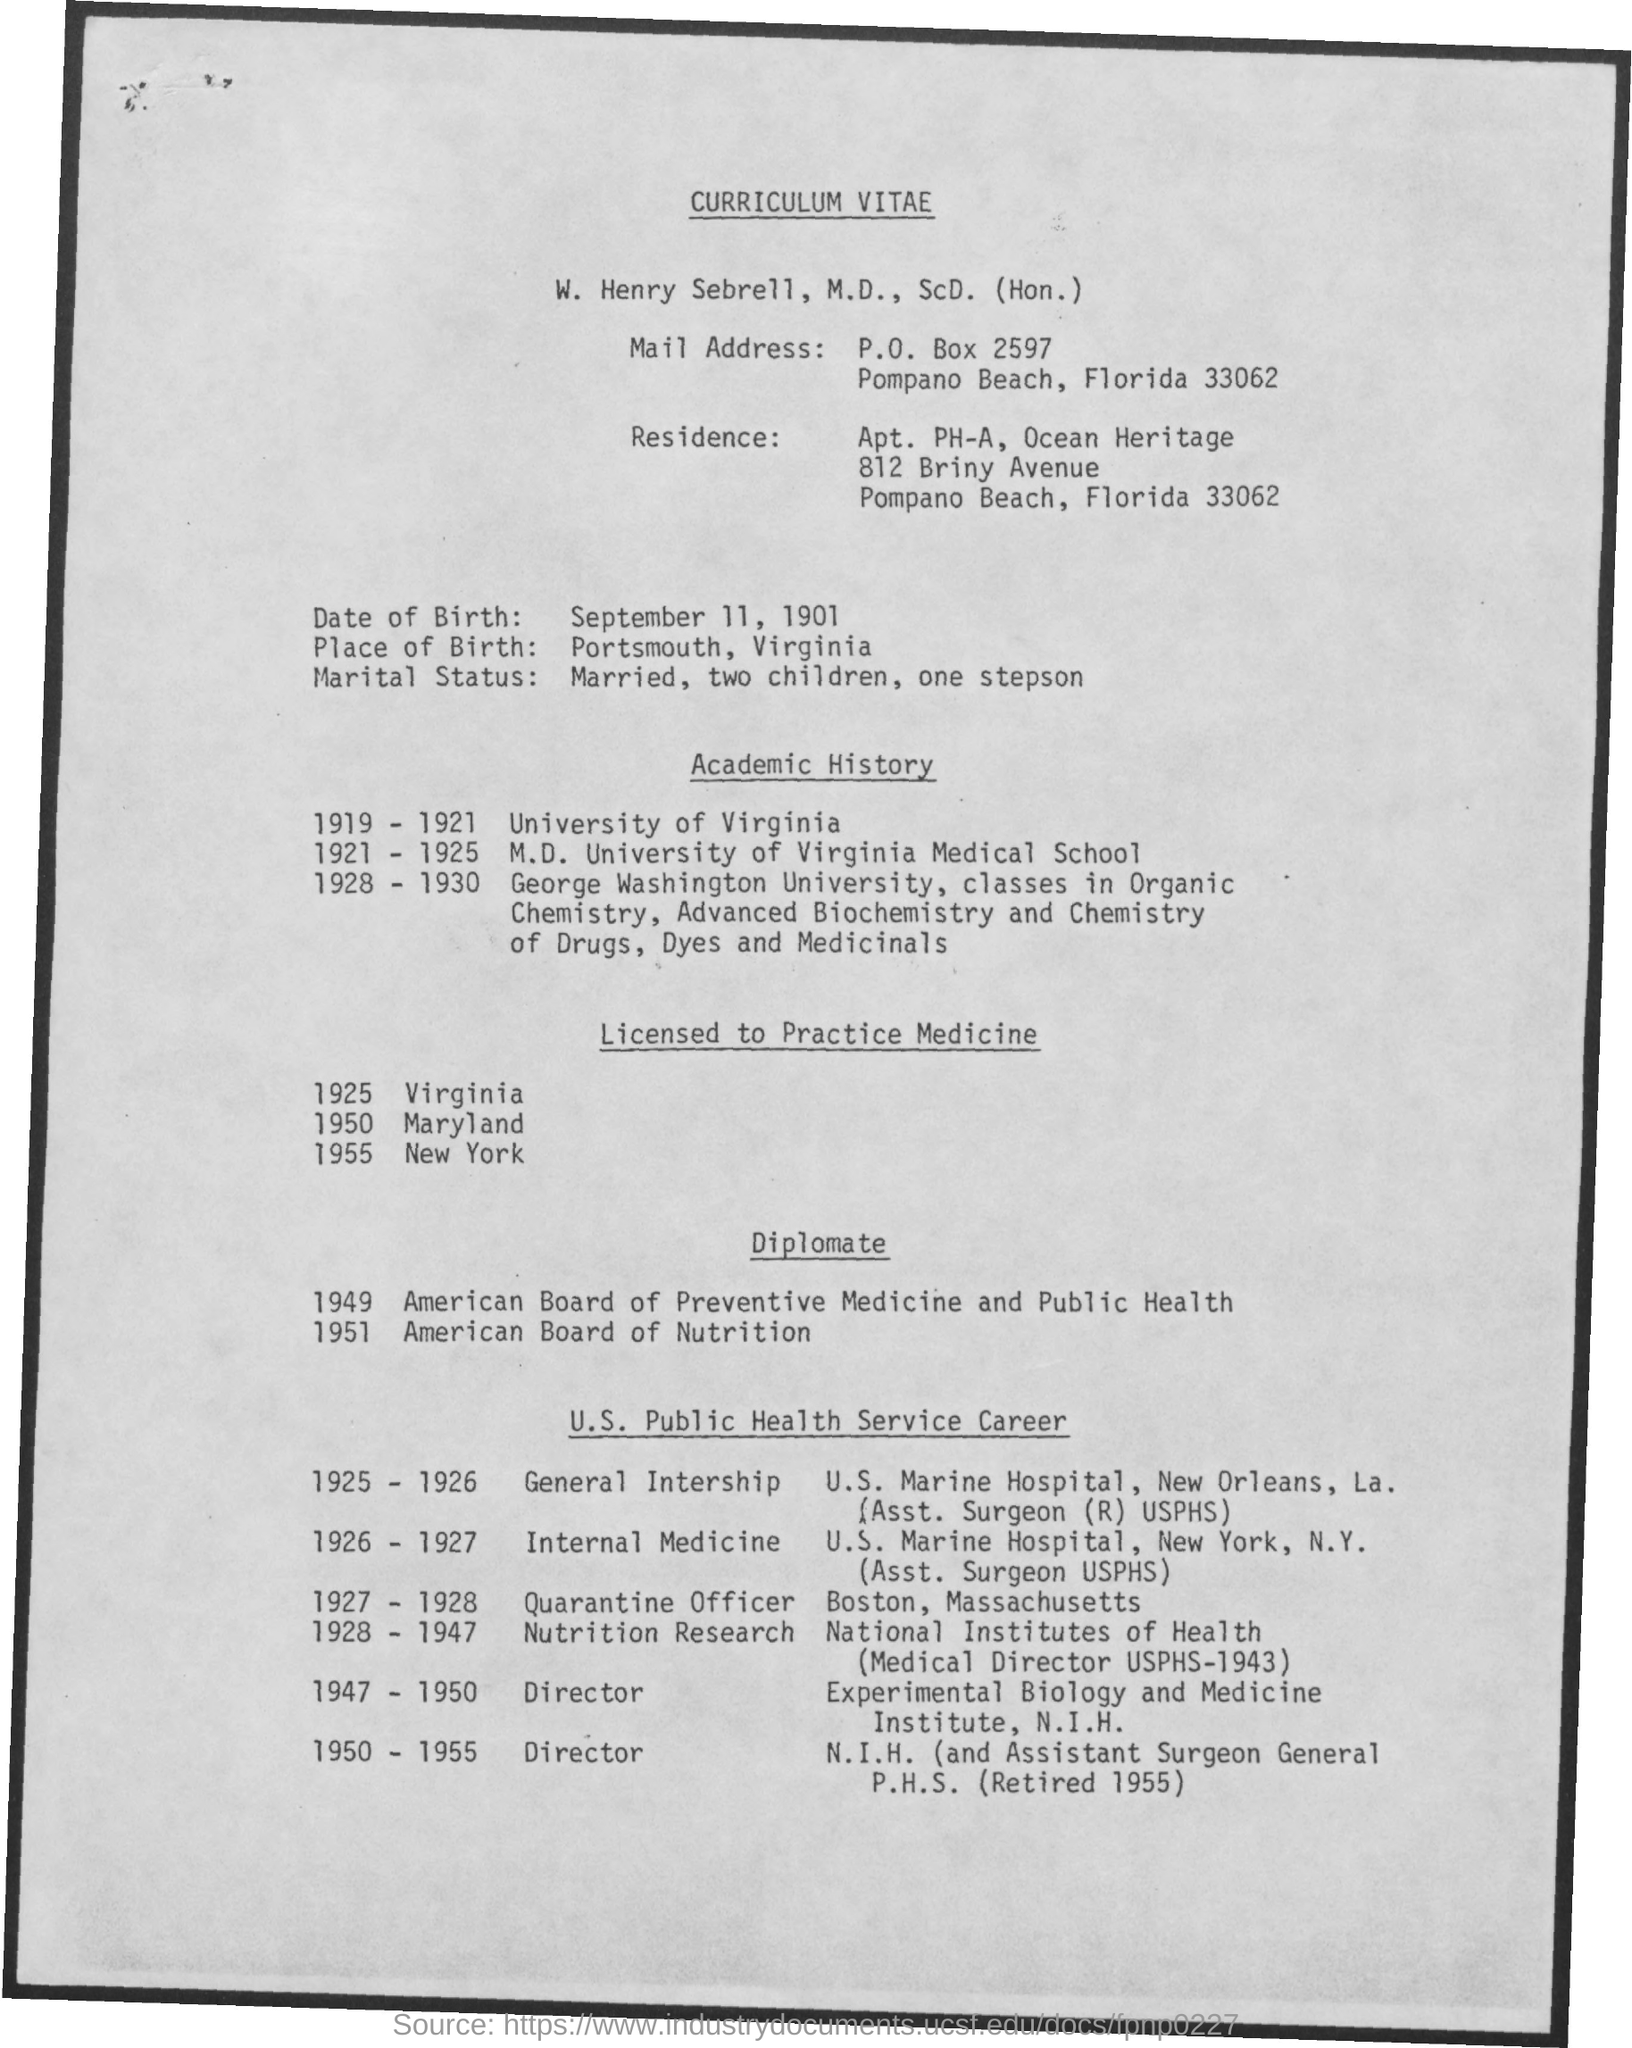What is the Title of the document?
Give a very brief answer. Curriculum Vitae. What is the Place of Birth?
Provide a short and direct response. Portsmouth, Virginia. When was he in University of Virginia?
Your answer should be very brief. 1919 - 1921. When was he licenced to practice in Virginia?
Offer a very short reply. 1925. When was he licenced to practice in Maryland?
Your answer should be compact. 1950. When was he licenced to practice in New York?
Your answer should be compact. 1955. 